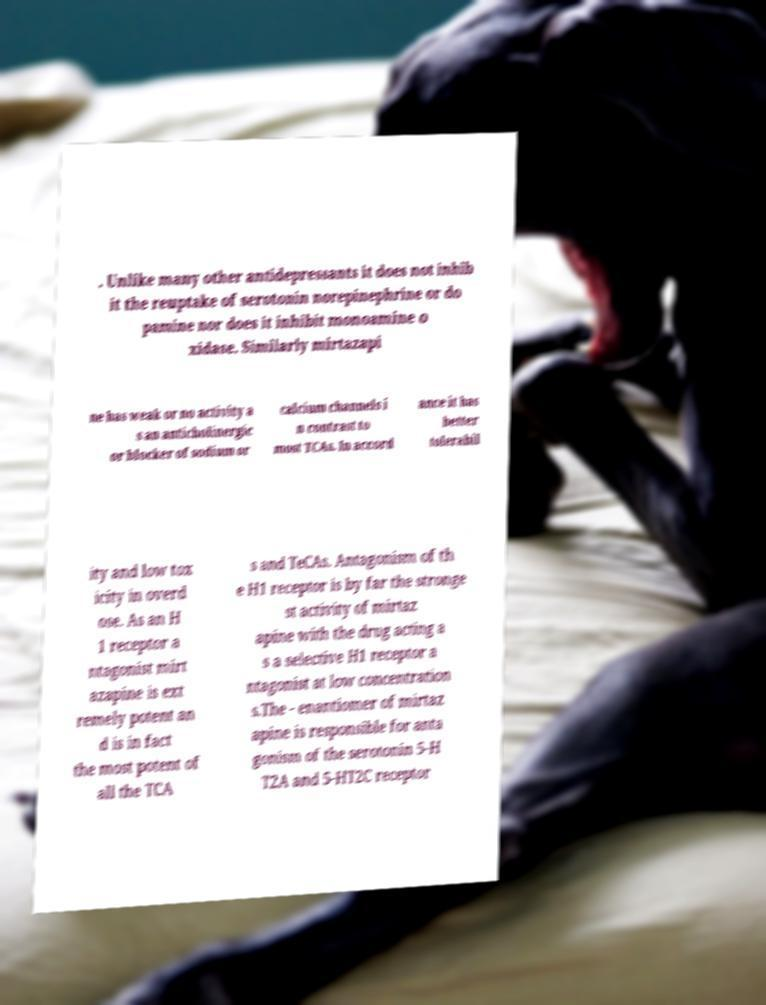What messages or text are displayed in this image? I need them in a readable, typed format. . Unlike many other antidepressants it does not inhib it the reuptake of serotonin norepinephrine or do pamine nor does it inhibit monoamine o xidase. Similarly mirtazapi ne has weak or no activity a s an anticholinergic or blocker of sodium or calcium channels i n contrast to most TCAs. In accord ance it has better tolerabil ity and low tox icity in overd ose. As an H 1 receptor a ntagonist mirt azapine is ext remely potent an d is in fact the most potent of all the TCA s and TeCAs. Antagonism of th e H1 receptor is by far the stronge st activity of mirtaz apine with the drug acting a s a selective H1 receptor a ntagonist at low concentration s.The - enantiomer of mirtaz apine is responsible for anta gonism of the serotonin 5-H T2A and 5-HT2C receptor 